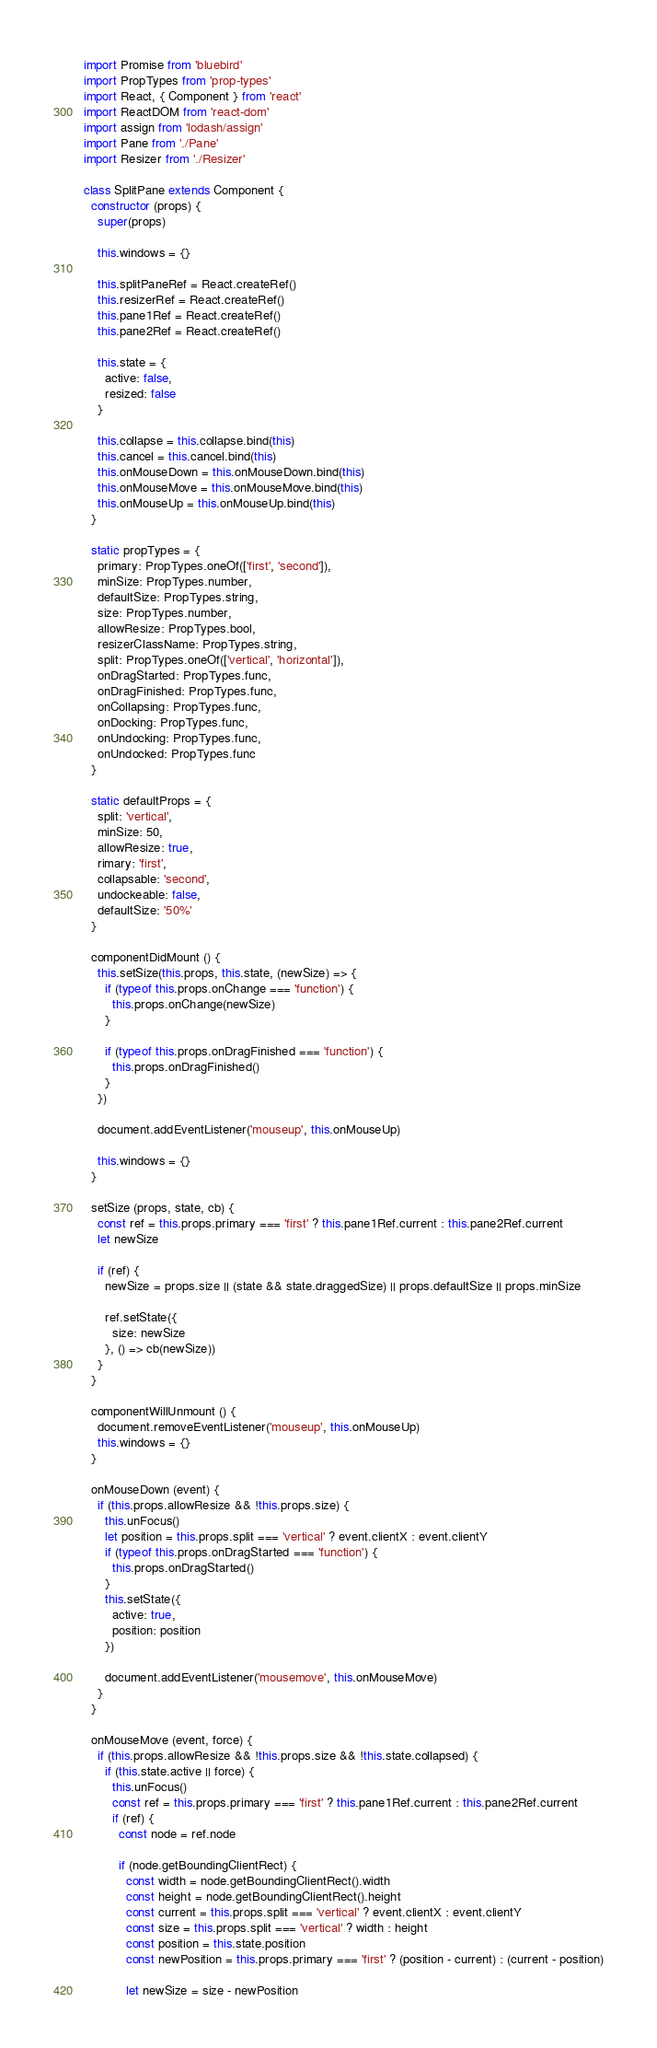Convert code to text. <code><loc_0><loc_0><loc_500><loc_500><_JavaScript_>import Promise from 'bluebird'
import PropTypes from 'prop-types'
import React, { Component } from 'react'
import ReactDOM from 'react-dom'
import assign from 'lodash/assign'
import Pane from './Pane'
import Resizer from './Resizer'

class SplitPane extends Component {
  constructor (props) {
    super(props)

    this.windows = {}

    this.splitPaneRef = React.createRef()
    this.resizerRef = React.createRef()
    this.pane1Ref = React.createRef()
    this.pane2Ref = React.createRef()

    this.state = {
      active: false,
      resized: false
    }

    this.collapse = this.collapse.bind(this)
    this.cancel = this.cancel.bind(this)
    this.onMouseDown = this.onMouseDown.bind(this)
    this.onMouseMove = this.onMouseMove.bind(this)
    this.onMouseUp = this.onMouseUp.bind(this)
  }

  static propTypes = {
    primary: PropTypes.oneOf(['first', 'second']),
    minSize: PropTypes.number,
    defaultSize: PropTypes.string,
    size: PropTypes.number,
    allowResize: PropTypes.bool,
    resizerClassName: PropTypes.string,
    split: PropTypes.oneOf(['vertical', 'horizontal']),
    onDragStarted: PropTypes.func,
    onDragFinished: PropTypes.func,
    onCollapsing: PropTypes.func,
    onDocking: PropTypes.func,
    onUndocking: PropTypes.func,
    onUndocked: PropTypes.func
  }

  static defaultProps = {
    split: 'vertical',
    minSize: 50,
    allowResize: true,
    rimary: 'first',
    collapsable: 'second',
    undockeable: false,
    defaultSize: '50%'
  }

  componentDidMount () {
    this.setSize(this.props, this.state, (newSize) => {
      if (typeof this.props.onChange === 'function') {
        this.props.onChange(newSize)
      }

      if (typeof this.props.onDragFinished === 'function') {
        this.props.onDragFinished()
      }
    })

    document.addEventListener('mouseup', this.onMouseUp)

    this.windows = {}
  }

  setSize (props, state, cb) {
    const ref = this.props.primary === 'first' ? this.pane1Ref.current : this.pane2Ref.current
    let newSize

    if (ref) {
      newSize = props.size || (state && state.draggedSize) || props.defaultSize || props.minSize

      ref.setState({
        size: newSize
      }, () => cb(newSize))
    }
  }

  componentWillUnmount () {
    document.removeEventListener('mouseup', this.onMouseUp)
    this.windows = {}
  }

  onMouseDown (event) {
    if (this.props.allowResize && !this.props.size) {
      this.unFocus()
      let position = this.props.split === 'vertical' ? event.clientX : event.clientY
      if (typeof this.props.onDragStarted === 'function') {
        this.props.onDragStarted()
      }
      this.setState({
        active: true,
        position: position
      })

      document.addEventListener('mousemove', this.onMouseMove)
    }
  }

  onMouseMove (event, force) {
    if (this.props.allowResize && !this.props.size && !this.state.collapsed) {
      if (this.state.active || force) {
        this.unFocus()
        const ref = this.props.primary === 'first' ? this.pane1Ref.current : this.pane2Ref.current
        if (ref) {
          const node = ref.node

          if (node.getBoundingClientRect) {
            const width = node.getBoundingClientRect().width
            const height = node.getBoundingClientRect().height
            const current = this.props.split === 'vertical' ? event.clientX : event.clientY
            const size = this.props.split === 'vertical' ? width : height
            const position = this.state.position
            const newPosition = this.props.primary === 'first' ? (position - current) : (current - position)

            let newSize = size - newPosition
</code> 